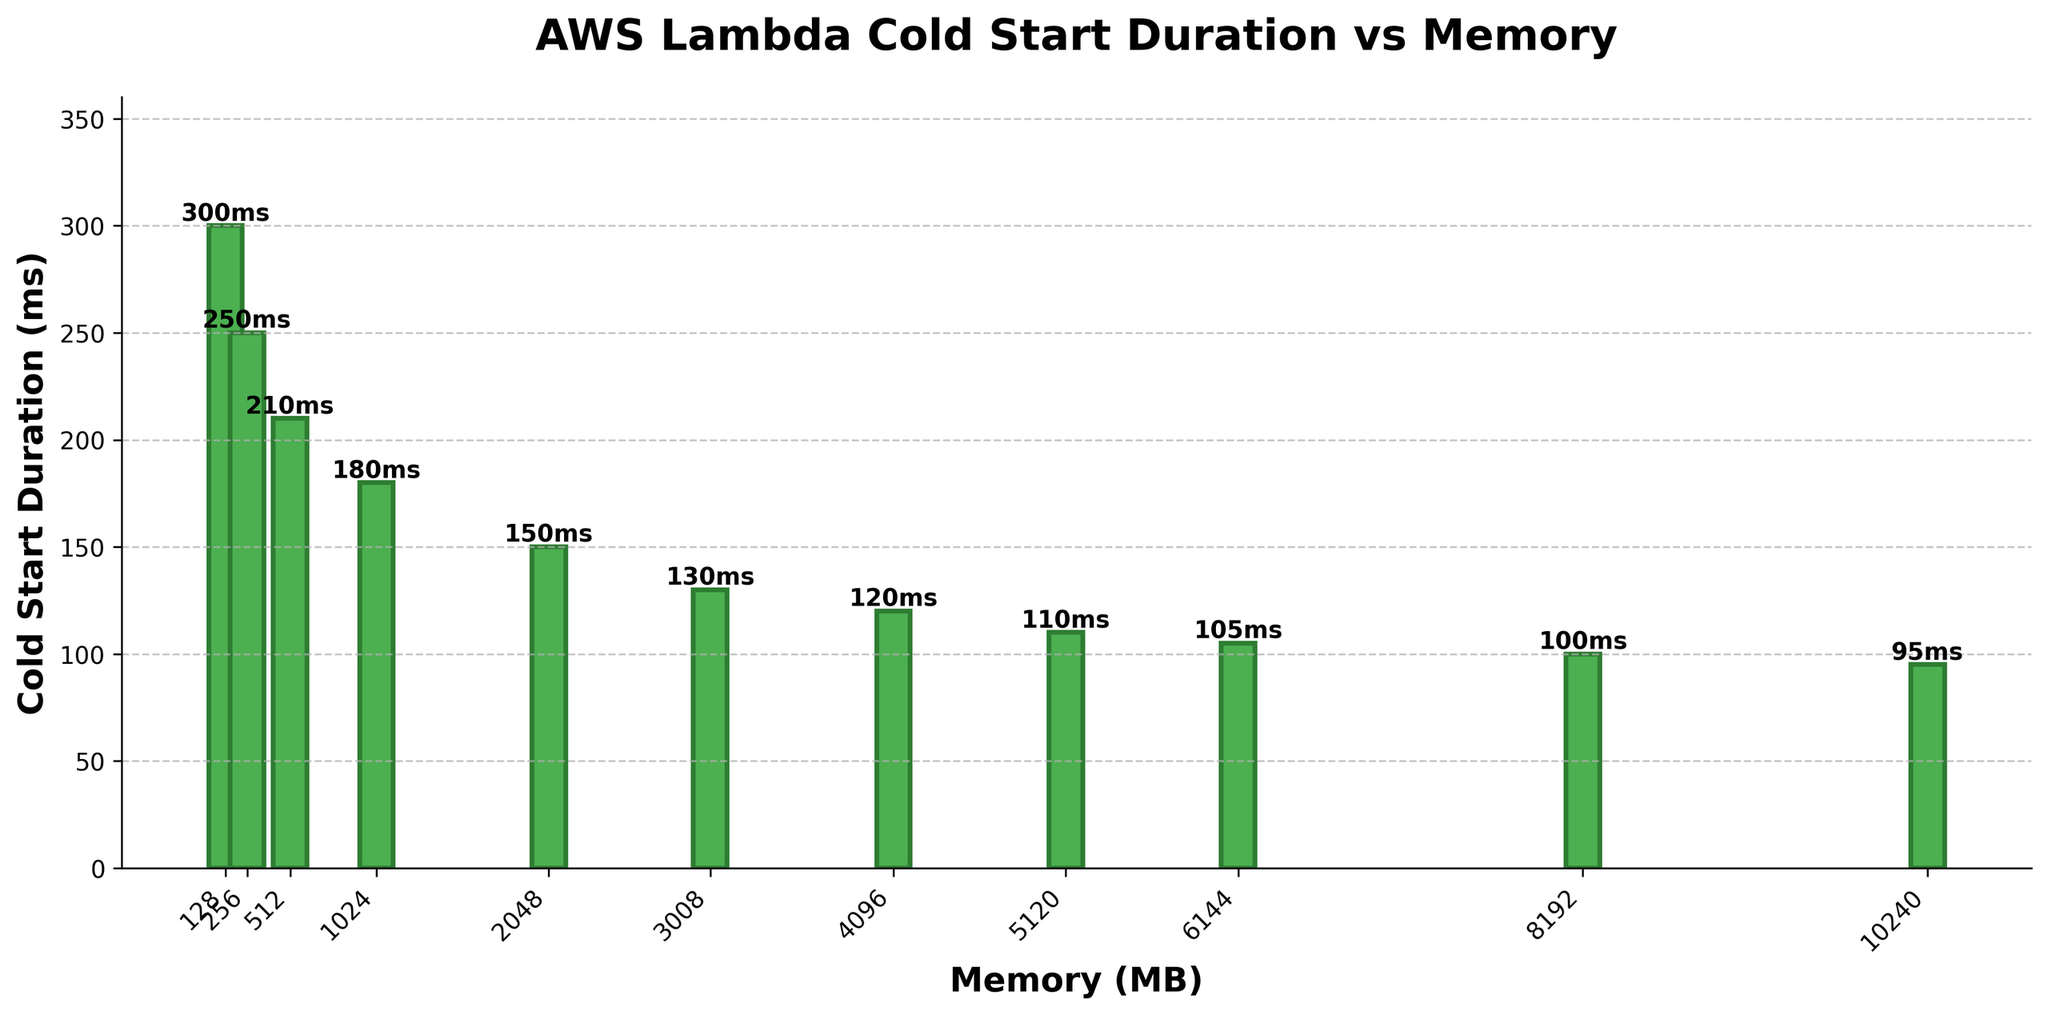What is the cold start duration for the function with 2048 MB memory? Locate the bar labeled "2048" on the x-axis and read its height, which is "150 ms"
Answer: 150 ms Which memory size has the highest cold start duration? Identify the highest bar on the chart, which corresponds to the "128 MB" memory size with "300 ms" cold start duration
Answer: 128 MB Is the cold start duration of a function with 4096 MB memory greater than that of a function with 1024 MB memory? Compare the bar heights for "4096 MB" and "1024 MB"; "4096 MB" has a height of 120 ms, while "1024 MB" has 180 ms
Answer: No What is the difference in cold start duration between functions with 512 MB and 256 MB memory? Subtract the height of the "256 MB" bar (250 ms) from the "512 MB" bar (210 ms): 250 ms - 210 ms = 40 ms
Answer: 40 ms What is the average cold start duration for function memory sizes of 128 MB, 256 MB, and 512 MB? Add the durations for "128 MB" (300 ms), "256 MB" (250 ms), and "512 MB" (210 ms) and divide by 3: (300 ms + 250 ms + 210 ms) / 3 = 253.33 ms
Answer: 253.33 ms Which memory sizes have cold start durations below 150 ms? Identify bars with heights less than 150 ms: "4096 MB", "5120 MB", "6144 MB", "8192 MB", "10240 MB" with durations of 120 ms, 110 ms, 105 ms, 100 ms, and 95 ms respectively
Answer: 4096 MB, 5120 MB, 6144 MB, 8192 MB, 10240 MB Describe the trend observed in the cold start durations as memory size increases. As memory size increases, the cold start duration generally decreases, indicated by progressively shorter bar heights from left to right
Answer: Decreasing trend What is the range of cold start durations in the data? Subtract the minimum duration (95 ms for 10240 MB) from the maximum duration (300 ms for 128 MB): 300 ms - 95 ms = 205 ms
Answer: 205 ms How does the cold start duration change between memory sizes of 1024 MB and 8192 MB? The duration changes from 180 ms (1024 MB) to 100 ms (8192 MB), a difference of 80 ms
Answer: Decreases by 80 ms 